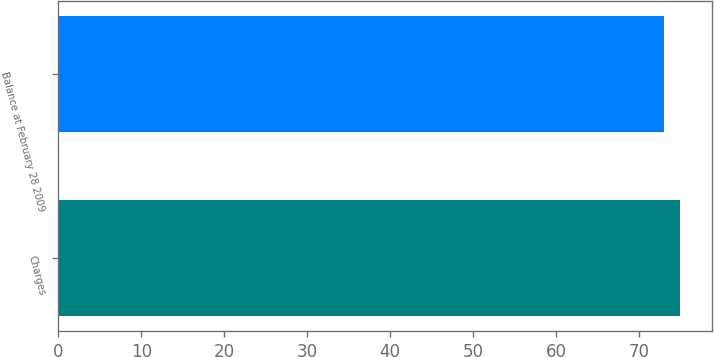Convert chart. <chart><loc_0><loc_0><loc_500><loc_500><bar_chart><fcel>Charges<fcel>Balance at February 28 2009<nl><fcel>75<fcel>73<nl></chart> 